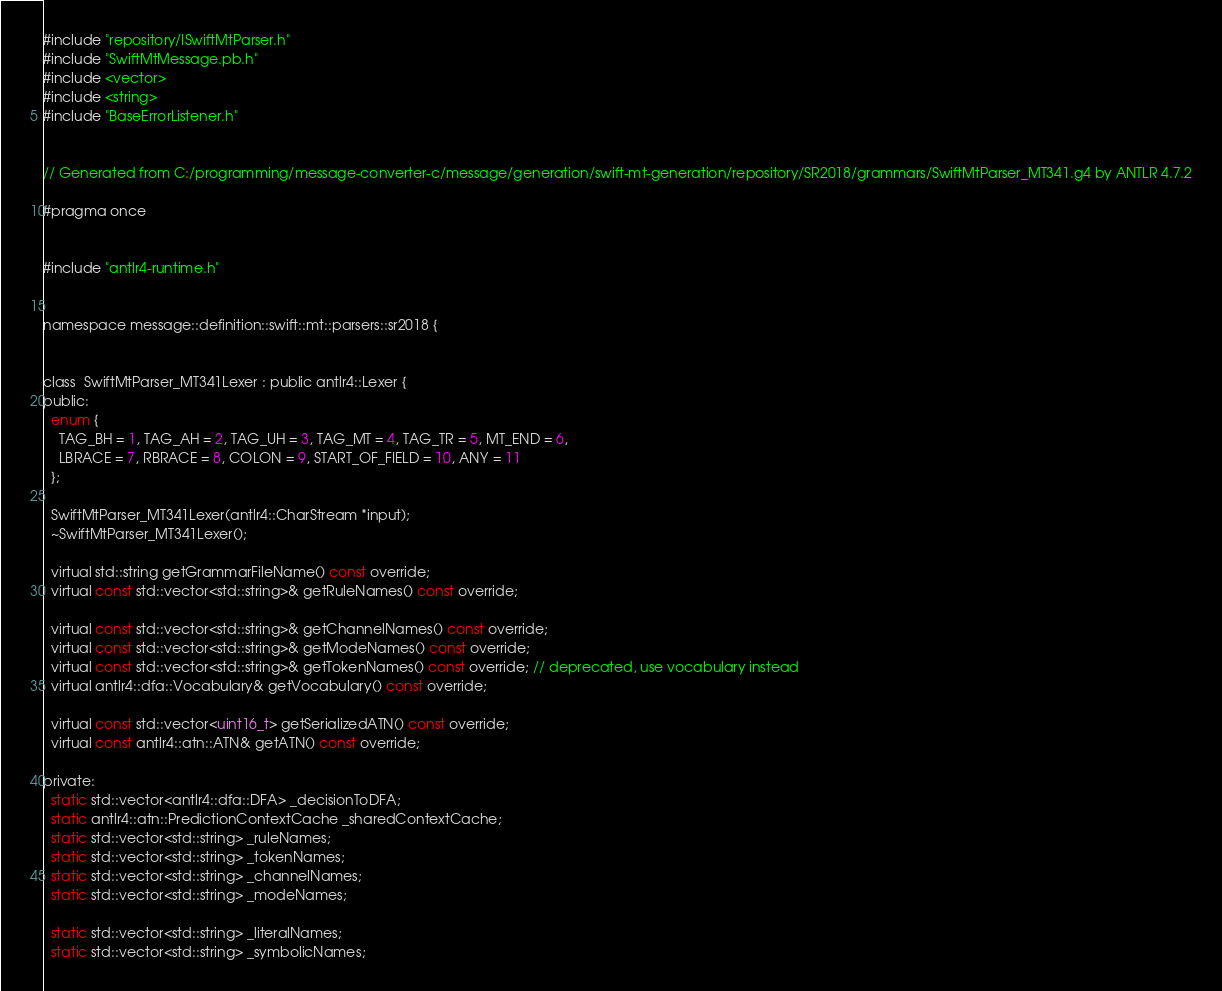<code> <loc_0><loc_0><loc_500><loc_500><_C_>
#include "repository/ISwiftMtParser.h"
#include "SwiftMtMessage.pb.h"
#include <vector>
#include <string>
#include "BaseErrorListener.h"


// Generated from C:/programming/message-converter-c/message/generation/swift-mt-generation/repository/SR2018/grammars/SwiftMtParser_MT341.g4 by ANTLR 4.7.2

#pragma once


#include "antlr4-runtime.h"


namespace message::definition::swift::mt::parsers::sr2018 {


class  SwiftMtParser_MT341Lexer : public antlr4::Lexer {
public:
  enum {
    TAG_BH = 1, TAG_AH = 2, TAG_UH = 3, TAG_MT = 4, TAG_TR = 5, MT_END = 6, 
    LBRACE = 7, RBRACE = 8, COLON = 9, START_OF_FIELD = 10, ANY = 11
  };

  SwiftMtParser_MT341Lexer(antlr4::CharStream *input);
  ~SwiftMtParser_MT341Lexer();

  virtual std::string getGrammarFileName() const override;
  virtual const std::vector<std::string>& getRuleNames() const override;

  virtual const std::vector<std::string>& getChannelNames() const override;
  virtual const std::vector<std::string>& getModeNames() const override;
  virtual const std::vector<std::string>& getTokenNames() const override; // deprecated, use vocabulary instead
  virtual antlr4::dfa::Vocabulary& getVocabulary() const override;

  virtual const std::vector<uint16_t> getSerializedATN() const override;
  virtual const antlr4::atn::ATN& getATN() const override;

private:
  static std::vector<antlr4::dfa::DFA> _decisionToDFA;
  static antlr4::atn::PredictionContextCache _sharedContextCache;
  static std::vector<std::string> _ruleNames;
  static std::vector<std::string> _tokenNames;
  static std::vector<std::string> _channelNames;
  static std::vector<std::string> _modeNames;

  static std::vector<std::string> _literalNames;
  static std::vector<std::string> _symbolicNames;</code> 